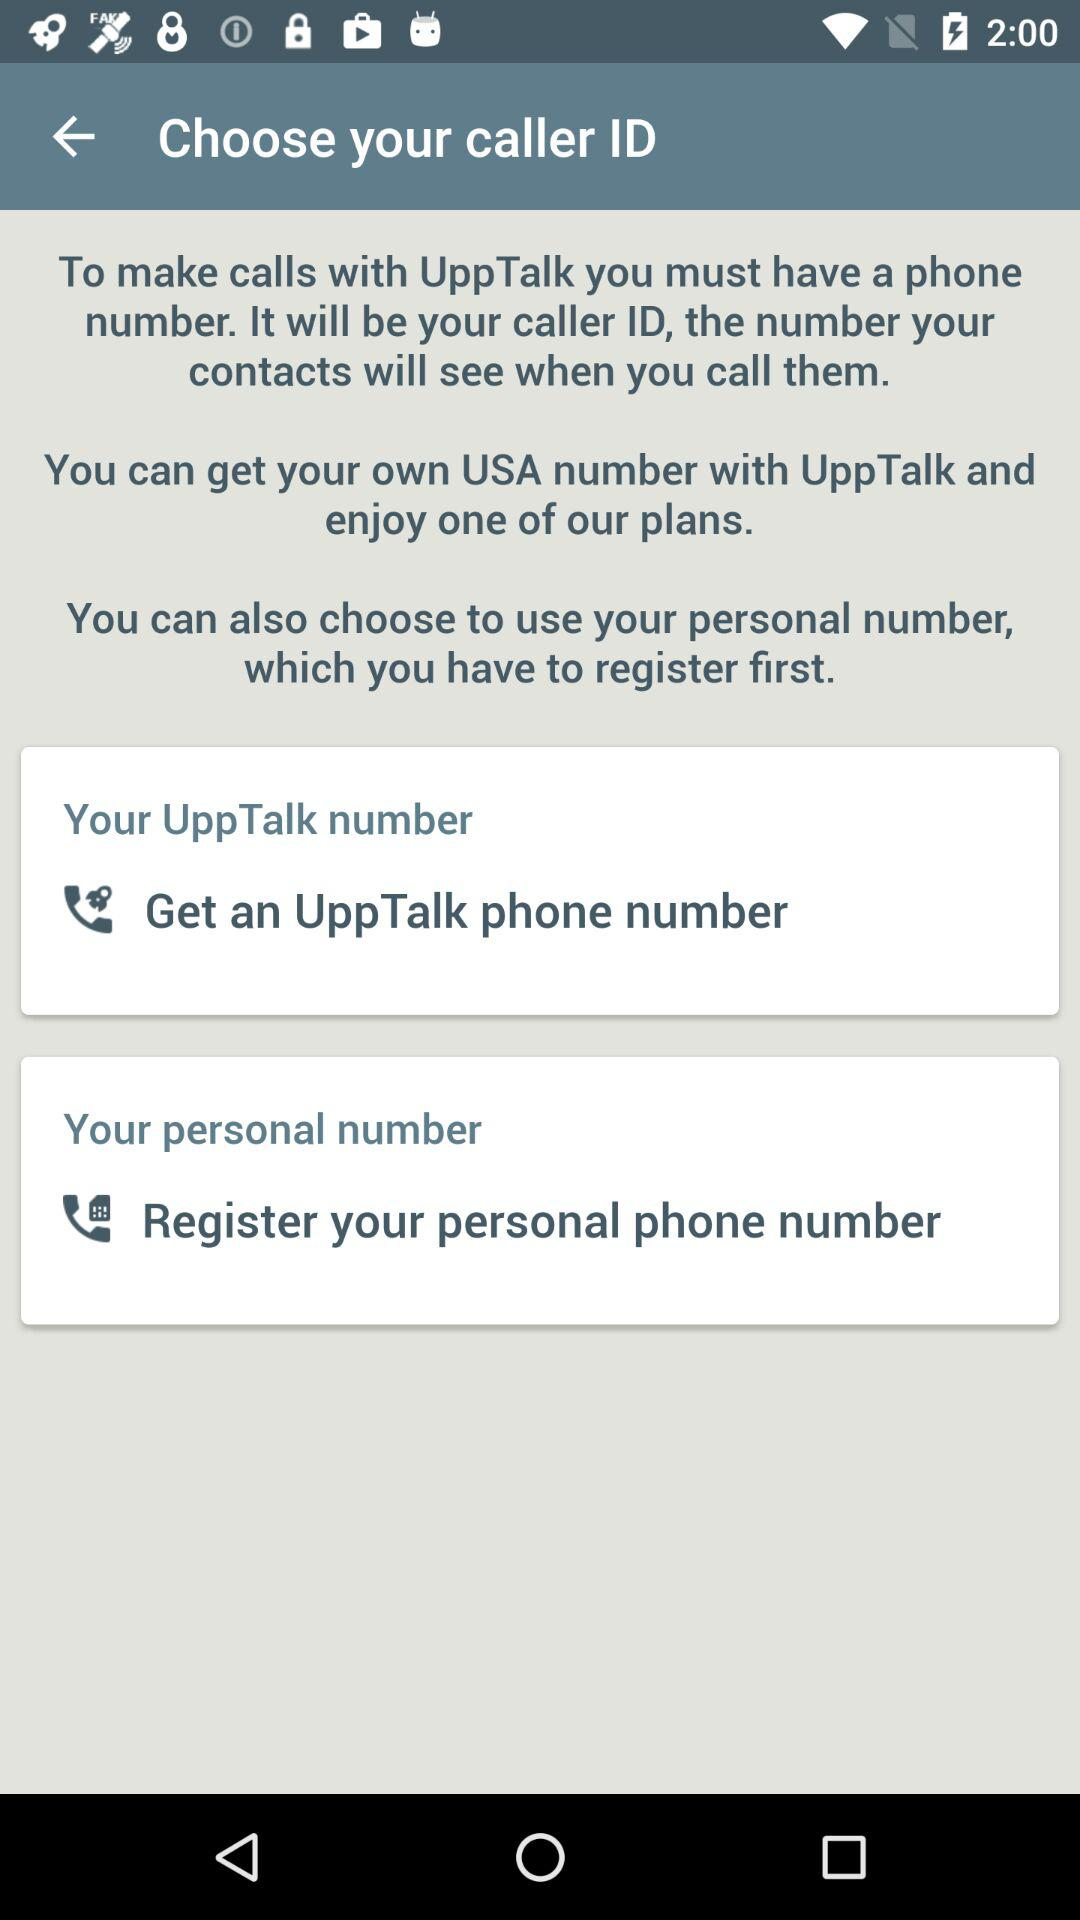How many options do I have for my caller ID?
Answer the question using a single word or phrase. 2 